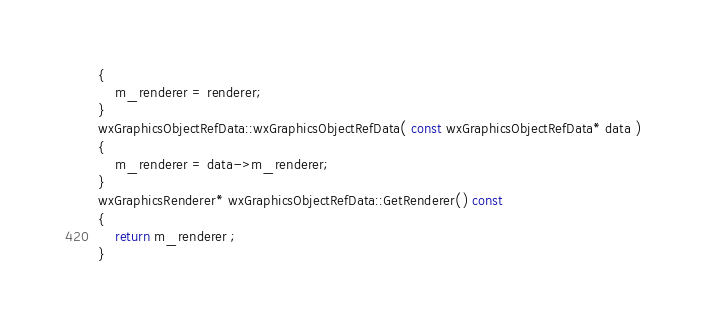Convert code to text. <code><loc_0><loc_0><loc_500><loc_500><_C++_>{
    m_renderer = renderer;
}
wxGraphicsObjectRefData::wxGraphicsObjectRefData( const wxGraphicsObjectRefData* data )
{
    m_renderer = data->m_renderer;
}
wxGraphicsRenderer* wxGraphicsObjectRefData::GetRenderer() const
{
    return m_renderer ;
}
</code> 